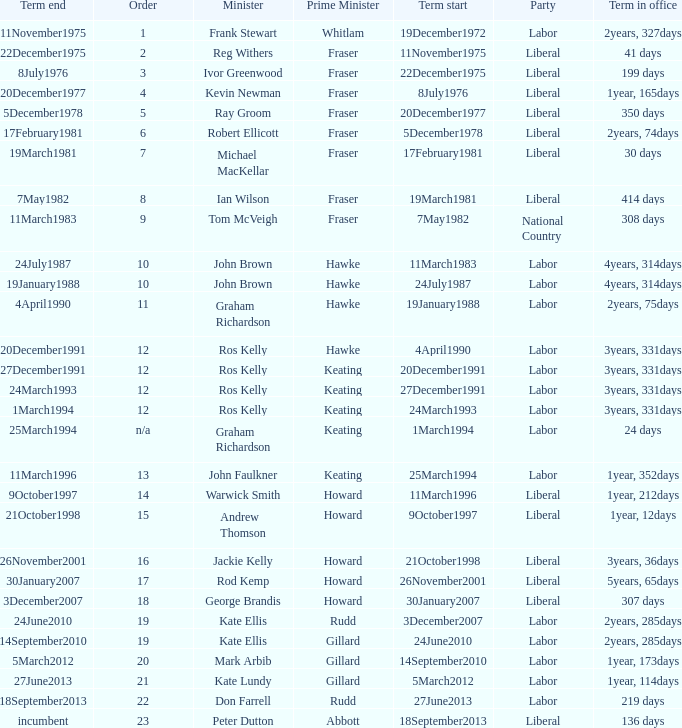What is the Term in office with an Order that is 9? 308 days. 